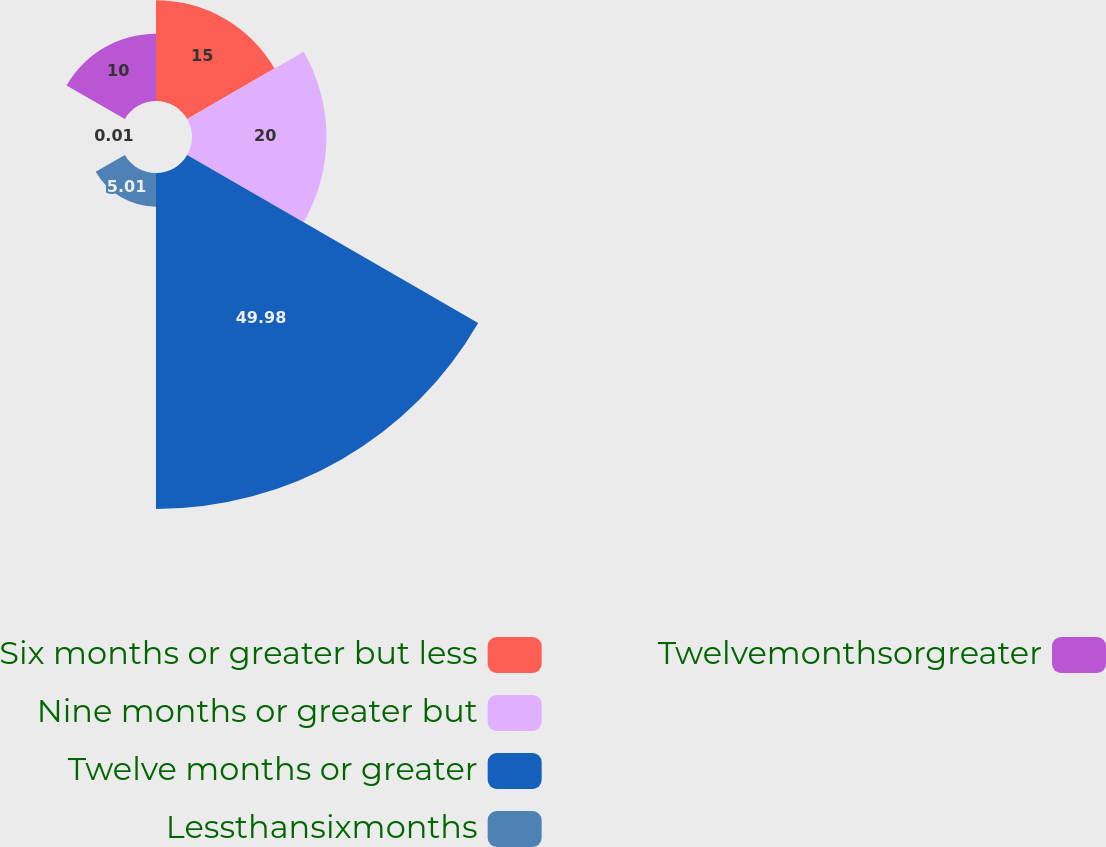Convert chart to OTSL. <chart><loc_0><loc_0><loc_500><loc_500><pie_chart><fcel>Six months or greater but less<fcel>Nine months or greater but<fcel>Twelve months or greater<fcel>Lessthansixmonths<fcel>Unnamed: 4<fcel>Twelvemonthsorgreater<nl><fcel>15.0%<fcel>20.0%<fcel>49.98%<fcel>5.01%<fcel>0.01%<fcel>10.0%<nl></chart> 